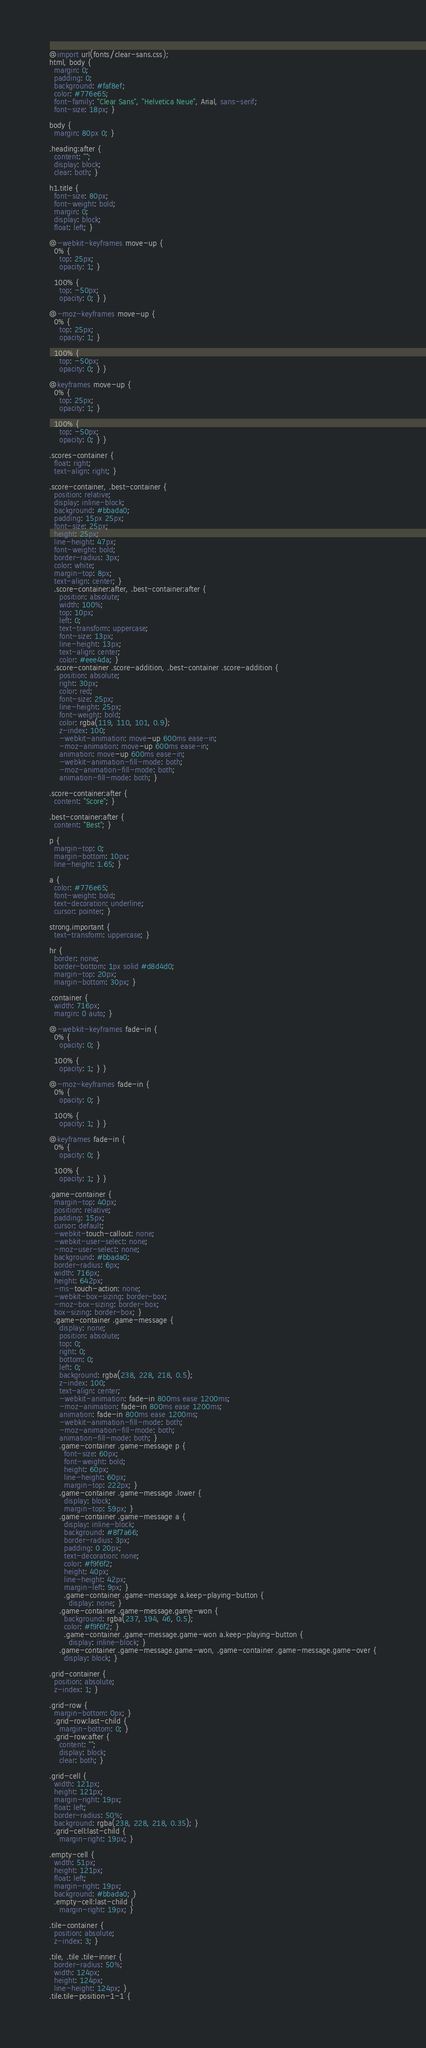<code> <loc_0><loc_0><loc_500><loc_500><_CSS_>@import url(fonts/clear-sans.css);
html, body {
  margin: 0;
  padding: 0;
  background: #faf8ef;
  color: #776e65;
  font-family: "Clear Sans", "Helvetica Neue", Arial, sans-serif;
  font-size: 18px; }

body {
  margin: 80px 0; }

.heading:after {
  content: "";
  display: block;
  clear: both; }

h1.title {
  font-size: 80px;
  font-weight: bold;
  margin: 0;
  display: block;
  float: left; }

@-webkit-keyframes move-up {
  0% {
    top: 25px;
    opacity: 1; }

  100% {
    top: -50px;
    opacity: 0; } }

@-moz-keyframes move-up {
  0% {
    top: 25px;
    opacity: 1; }

  100% {
    top: -50px;
    opacity: 0; } }

@keyframes move-up {
  0% {
    top: 25px;
    opacity: 1; }

  100% {
    top: -50px;
    opacity: 0; } }

.scores-container {
  float: right;
  text-align: right; }

.score-container, .best-container {
  position: relative;
  display: inline-block;
  background: #bbada0;
  padding: 15px 25px;
  font-size: 25px;
  height: 25px;
  line-height: 47px;
  font-weight: bold;
  border-radius: 3px;
  color: white;
  margin-top: 8px;
  text-align: center; }
  .score-container:after, .best-container:after {
    position: absolute;
    width: 100%;
    top: 10px;
    left: 0;
    text-transform: uppercase;
    font-size: 13px;
    line-height: 13px;
    text-align: center;
    color: #eee4da; }
  .score-container .score-addition, .best-container .score-addition {
    position: absolute;
    right: 30px;
    color: red;
    font-size: 25px;
    line-height: 25px;
    font-weight: bold;
    color: rgba(119, 110, 101, 0.9);
    z-index: 100;
    -webkit-animation: move-up 600ms ease-in;
    -moz-animation: move-up 600ms ease-in;
    animation: move-up 600ms ease-in;
    -webkit-animation-fill-mode: both;
    -moz-animation-fill-mode: both;
    animation-fill-mode: both; }

.score-container:after {
  content: "Score"; }

.best-container:after {
  content: "Best"; }

p {
  margin-top: 0;
  margin-bottom: 10px;
  line-height: 1.65; }

a {
  color: #776e65;
  font-weight: bold;
  text-decoration: underline;
  cursor: pointer; }

strong.important {
  text-transform: uppercase; }

hr {
  border: none;
  border-bottom: 1px solid #d8d4d0;
  margin-top: 20px;
  margin-bottom: 30px; }

.container {
  width: 716px;
  margin: 0 auto; }

@-webkit-keyframes fade-in {
  0% {
    opacity: 0; }

  100% {
    opacity: 1; } }

@-moz-keyframes fade-in {
  0% {
    opacity: 0; }

  100% {
    opacity: 1; } }

@keyframes fade-in {
  0% {
    opacity: 0; }

  100% {
    opacity: 1; } }

.game-container {
  margin-top: 40px;
  position: relative;
  padding: 15px;
  cursor: default;
  -webkit-touch-callout: none;
  -webkit-user-select: none;
  -moz-user-select: none;
  background: #bbada0;
  border-radius: 6px;
  width: 716px;
  height: 642px;
  -ms-touch-action: none;
  -webkit-box-sizing: border-box;
  -moz-box-sizing: border-box;
  box-sizing: border-box; }
  .game-container .game-message {
    display: none;
    position: absolute;
    top: 0;
    right: 0;
    bottom: 0;
    left: 0;
    background: rgba(238, 228, 218, 0.5);
    z-index: 100;
    text-align: center;
    -webkit-animation: fade-in 800ms ease 1200ms;
    -moz-animation: fade-in 800ms ease 1200ms;
    animation: fade-in 800ms ease 1200ms;
    -webkit-animation-fill-mode: both;
    -moz-animation-fill-mode: both;
    animation-fill-mode: both; }
    .game-container .game-message p {
      font-size: 60px;
      font-weight: bold;
      height: 60px;
      line-height: 60px;
      margin-top: 222px; }
    .game-container .game-message .lower {
      display: block;
      margin-top: 59px; }
    .game-container .game-message a {
      display: inline-block;
      background: #8f7a66;
      border-radius: 3px;
      padding: 0 20px;
      text-decoration: none;
      color: #f9f6f2;
      height: 40px;
      line-height: 42px;
      margin-left: 9px; }
      .game-container .game-message a.keep-playing-button {
        display: none; }
    .game-container .game-message.game-won {
      background: rgba(237, 194, 46, 0.5);
      color: #f9f6f2; }
      .game-container .game-message.game-won a.keep-playing-button {
        display: inline-block; }
    .game-container .game-message.game-won, .game-container .game-message.game-over {
      display: block; }

.grid-container {
  position: absolute;
  z-index: 1; }

.grid-row {
  margin-bottom: 0px; }
  .grid-row:last-child {
    margin-bottom: 0; }
  .grid-row:after {
    content: "";
    display: block;
    clear: both; }

.grid-cell {
  width: 121px;
  height: 121px;
  margin-right: 19px;
  float: left;
  border-radius: 50%;
  background: rgba(238, 228, 218, 0.35); }
  .grid-cell:last-child {
    margin-right: 19px; }

.empty-cell {
  width: 51px;
  height: 121px;
  float: left;
  margin-right: 19px;
  background: #bbada0; }
  .empty-cell:last-child {
    margin-right: 19px; }
 
.tile-container {
  position: absolute;
  z-index: 3; }

.tile, .tile .tile-inner {
  border-radius: 50%;
  width: 124px;
  height: 124px;
  line-height: 124px; }
.tile.tile-position-1-1 {</code> 